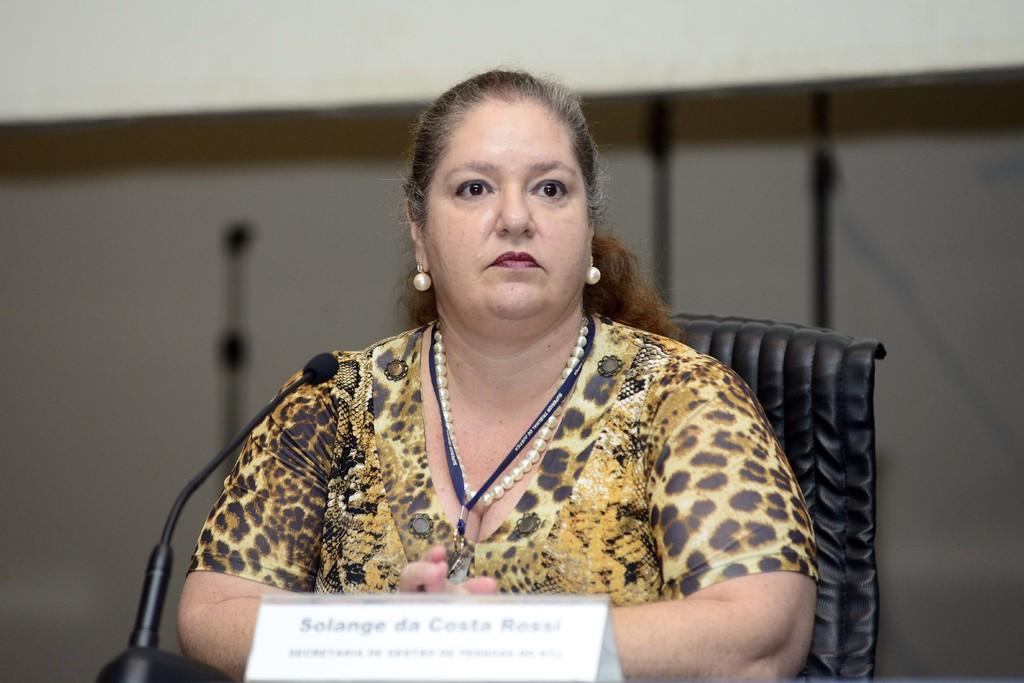Who or what is present in the image? There is a person in the image. What is the person sitting on? There is a chair in the image. What is the person holding or using? There is a microphone in the image. What can be seen on the table or desk? There is a name plate in the image. Can you describe the setting or environment in the image? There is a wall in the background of the image, and there are other objects in the background as well. What type of drawer can be seen in the image? There is no drawer present in the image. What form does the person's shadow take in the image? There is no mention of a shadow in the image, so it cannot be determined. 